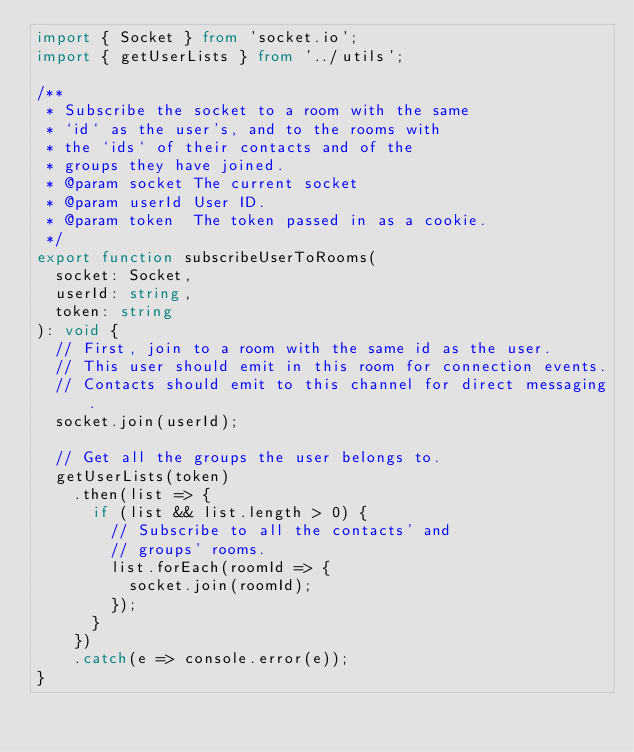<code> <loc_0><loc_0><loc_500><loc_500><_TypeScript_>import { Socket } from 'socket.io';
import { getUserLists } from '../utils';

/**
 * Subscribe the socket to a room with the same
 * `id` as the user's, and to the rooms with
 * the `ids` of their contacts and of the
 * groups they have joined.
 * @param socket The current socket
 * @param userId User ID.
 * @param token  The token passed in as a cookie.
 */
export function subscribeUserToRooms(
  socket: Socket,
  userId: string,
  token: string
): void {
  // First, join to a room with the same id as the user.
  // This user should emit in this room for connection events.
  // Contacts should emit to this channel for direct messaging.
  socket.join(userId);

  // Get all the groups the user belongs to.
  getUserLists(token)
    .then(list => {
      if (list && list.length > 0) {
        // Subscribe to all the contacts' and
        // groups' rooms.
        list.forEach(roomId => {
          socket.join(roomId);
        });
      }
    })
    .catch(e => console.error(e));
}
</code> 